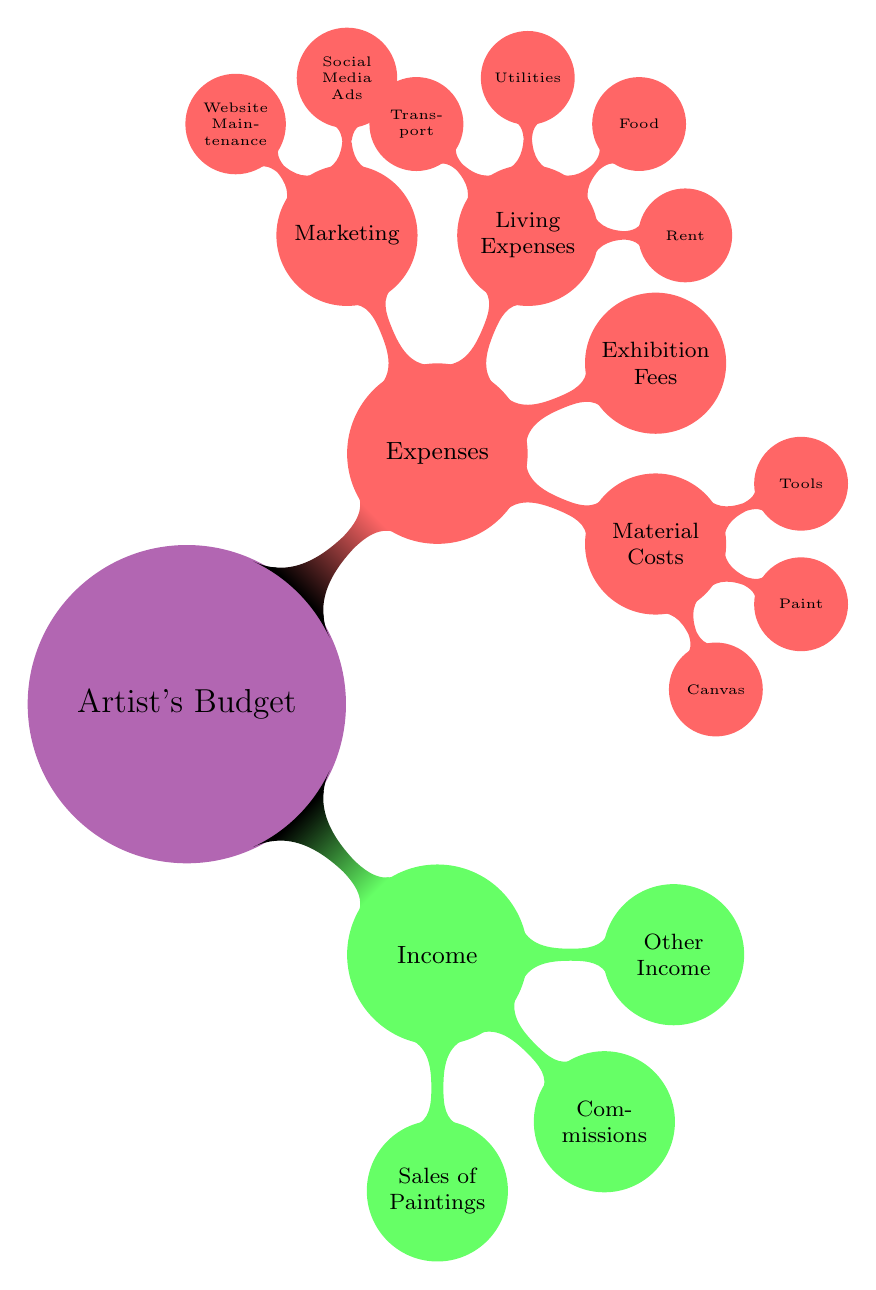What are the main categories of the artist's budget? The diagram shows two main categories for the artist's budget: Income and Expenses.
Answer: Income, Expenses How many sources of income are listed in the diagram? There are three sources of income listed under the Income category: Sales of Paintings, Commissions, and Other Income.
Answer: 3 What are some examples of material costs? The diagram outlines three examples of material costs: Canvas, Paint, and Tools under the Material Costs category.
Answer: Canvas, Paint, Tools Which category includes expenses for Rent and Food? The Living Expenses category falls under the Expenses category, which includes Rent and Food as examples of living expenses.
Answer: Living Expenses How many types of marketing expenses are mentioned? The diagram specifies two types of marketing expenses: Social Media Ads and Website Maintenance, which are under the Marketing category.
Answer: 2 What is the relationship between Expenses and Living Expenses in the diagram? Living Expenses is a subcategory that falls directly under the broader category of Expenses in the diagram.
Answer: Subcategory If the artist wants to reduce costs, which category should they focus on? To reduce overall costs, the artist should focus on the Expenses category since it encompasses all outgoing expenses, including Material Costs, Exhibition Fees, and Living Expenses.
Answer: Expenses What type of diagram is this? This is a mindmap diagram, which visually organizes information, showing the connections between different nodes related to the artist's budget.
Answer: Mindmap Which category would Marketing Expenses belong to? Marketing Expenses are categorized under Expenses in the diagram.
Answer: Expenses 